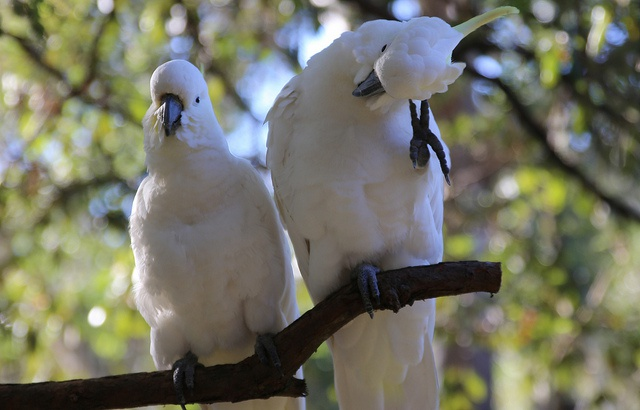Describe the objects in this image and their specific colors. I can see bird in darkgray, gray, and black tones and bird in darkgray, gray, and black tones in this image. 